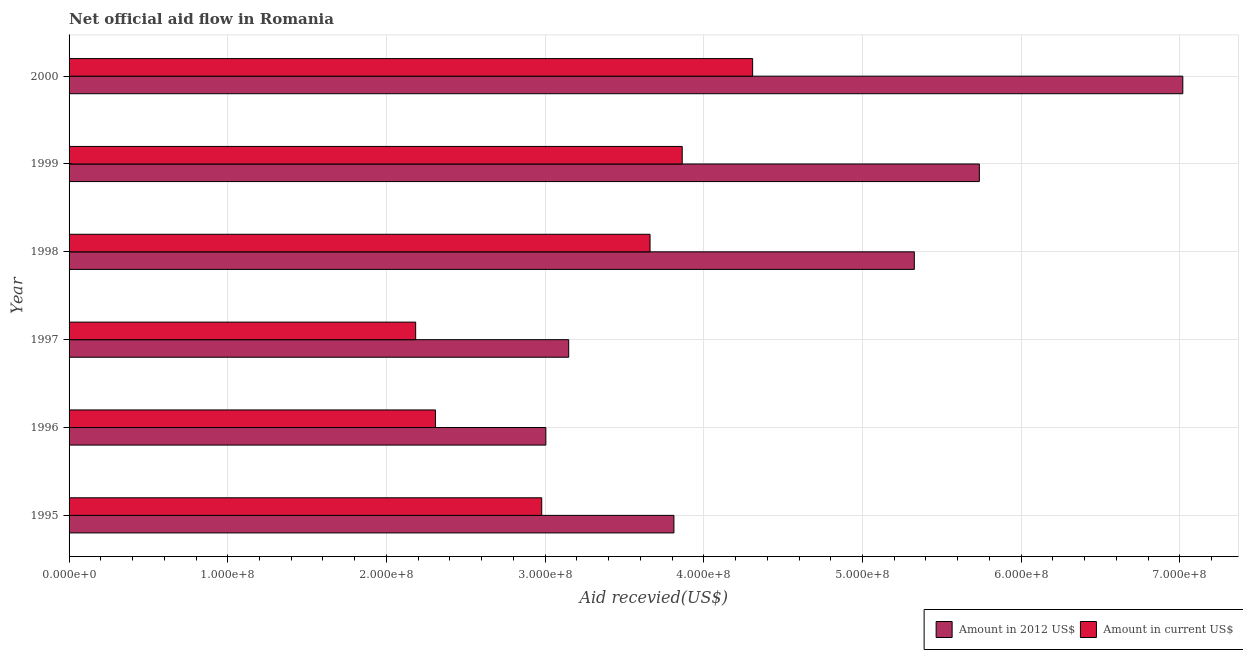How many groups of bars are there?
Provide a short and direct response. 6. Are the number of bars per tick equal to the number of legend labels?
Provide a short and direct response. Yes. How many bars are there on the 6th tick from the top?
Keep it short and to the point. 2. What is the label of the 6th group of bars from the top?
Your answer should be compact. 1995. In how many cases, is the number of bars for a given year not equal to the number of legend labels?
Make the answer very short. 0. What is the amount of aid received(expressed in us$) in 2000?
Provide a short and direct response. 4.31e+08. Across all years, what is the maximum amount of aid received(expressed in us$)?
Provide a succinct answer. 4.31e+08. Across all years, what is the minimum amount of aid received(expressed in 2012 us$)?
Provide a short and direct response. 3.00e+08. In which year was the amount of aid received(expressed in us$) maximum?
Make the answer very short. 2000. What is the total amount of aid received(expressed in 2012 us$) in the graph?
Your answer should be compact. 2.80e+09. What is the difference between the amount of aid received(expressed in us$) in 1995 and that in 1998?
Ensure brevity in your answer.  -6.83e+07. What is the difference between the amount of aid received(expressed in 2012 us$) in 1998 and the amount of aid received(expressed in us$) in 1999?
Your response must be concise. 1.46e+08. What is the average amount of aid received(expressed in 2012 us$) per year?
Ensure brevity in your answer.  4.67e+08. In the year 2000, what is the difference between the amount of aid received(expressed in us$) and amount of aid received(expressed in 2012 us$)?
Make the answer very short. -2.71e+08. In how many years, is the amount of aid received(expressed in us$) greater than 480000000 US$?
Keep it short and to the point. 0. What is the ratio of the amount of aid received(expressed in us$) in 1997 to that in 1999?
Your response must be concise. 0.56. Is the difference between the amount of aid received(expressed in 2012 us$) in 1998 and 2000 greater than the difference between the amount of aid received(expressed in us$) in 1998 and 2000?
Provide a succinct answer. No. What is the difference between the highest and the second highest amount of aid received(expressed in 2012 us$)?
Your answer should be compact. 1.28e+08. What is the difference between the highest and the lowest amount of aid received(expressed in us$)?
Provide a short and direct response. 2.12e+08. In how many years, is the amount of aid received(expressed in us$) greater than the average amount of aid received(expressed in us$) taken over all years?
Keep it short and to the point. 3. What does the 1st bar from the top in 1995 represents?
Offer a terse response. Amount in current US$. What does the 1st bar from the bottom in 1996 represents?
Make the answer very short. Amount in 2012 US$. How many bars are there?
Ensure brevity in your answer.  12. Are all the bars in the graph horizontal?
Your answer should be compact. Yes. What is the difference between two consecutive major ticks on the X-axis?
Offer a terse response. 1.00e+08. Are the values on the major ticks of X-axis written in scientific E-notation?
Provide a short and direct response. Yes. Does the graph contain grids?
Your response must be concise. Yes. How many legend labels are there?
Offer a very short reply. 2. How are the legend labels stacked?
Offer a terse response. Horizontal. What is the title of the graph?
Your answer should be compact. Net official aid flow in Romania. Does "Primary school" appear as one of the legend labels in the graph?
Offer a very short reply. No. What is the label or title of the X-axis?
Your answer should be compact. Aid recevied(US$). What is the label or title of the Y-axis?
Provide a succinct answer. Year. What is the Aid recevied(US$) of Amount in 2012 US$ in 1995?
Your response must be concise. 3.81e+08. What is the Aid recevied(US$) of Amount in current US$ in 1995?
Give a very brief answer. 2.98e+08. What is the Aid recevied(US$) in Amount in 2012 US$ in 1996?
Make the answer very short. 3.00e+08. What is the Aid recevied(US$) of Amount in current US$ in 1996?
Your answer should be compact. 2.31e+08. What is the Aid recevied(US$) of Amount in 2012 US$ in 1997?
Your response must be concise. 3.15e+08. What is the Aid recevied(US$) of Amount in current US$ in 1997?
Provide a succinct answer. 2.18e+08. What is the Aid recevied(US$) in Amount in 2012 US$ in 1998?
Offer a very short reply. 5.33e+08. What is the Aid recevied(US$) of Amount in current US$ in 1998?
Make the answer very short. 3.66e+08. What is the Aid recevied(US$) of Amount in 2012 US$ in 1999?
Provide a short and direct response. 5.74e+08. What is the Aid recevied(US$) of Amount in current US$ in 1999?
Provide a short and direct response. 3.86e+08. What is the Aid recevied(US$) in Amount in 2012 US$ in 2000?
Ensure brevity in your answer.  7.02e+08. What is the Aid recevied(US$) of Amount in current US$ in 2000?
Provide a short and direct response. 4.31e+08. Across all years, what is the maximum Aid recevied(US$) of Amount in 2012 US$?
Your response must be concise. 7.02e+08. Across all years, what is the maximum Aid recevied(US$) in Amount in current US$?
Ensure brevity in your answer.  4.31e+08. Across all years, what is the minimum Aid recevied(US$) in Amount in 2012 US$?
Ensure brevity in your answer.  3.00e+08. Across all years, what is the minimum Aid recevied(US$) of Amount in current US$?
Offer a terse response. 2.18e+08. What is the total Aid recevied(US$) in Amount in 2012 US$ in the graph?
Offer a terse response. 2.80e+09. What is the total Aid recevied(US$) in Amount in current US$ in the graph?
Provide a short and direct response. 1.93e+09. What is the difference between the Aid recevied(US$) of Amount in 2012 US$ in 1995 and that in 1996?
Your response must be concise. 8.07e+07. What is the difference between the Aid recevied(US$) in Amount in current US$ in 1995 and that in 1996?
Keep it short and to the point. 6.69e+07. What is the difference between the Aid recevied(US$) in Amount in 2012 US$ in 1995 and that in 1997?
Your answer should be compact. 6.63e+07. What is the difference between the Aid recevied(US$) of Amount in current US$ in 1995 and that in 1997?
Your answer should be very brief. 7.94e+07. What is the difference between the Aid recevied(US$) of Amount in 2012 US$ in 1995 and that in 1998?
Ensure brevity in your answer.  -1.52e+08. What is the difference between the Aid recevied(US$) in Amount in current US$ in 1995 and that in 1998?
Ensure brevity in your answer.  -6.83e+07. What is the difference between the Aid recevied(US$) in Amount in 2012 US$ in 1995 and that in 1999?
Give a very brief answer. -1.92e+08. What is the difference between the Aid recevied(US$) in Amount in current US$ in 1995 and that in 1999?
Provide a short and direct response. -8.85e+07. What is the difference between the Aid recevied(US$) in Amount in 2012 US$ in 1995 and that in 2000?
Offer a terse response. -3.21e+08. What is the difference between the Aid recevied(US$) of Amount in current US$ in 1995 and that in 2000?
Provide a succinct answer. -1.33e+08. What is the difference between the Aid recevied(US$) of Amount in 2012 US$ in 1996 and that in 1997?
Offer a terse response. -1.44e+07. What is the difference between the Aid recevied(US$) in Amount in current US$ in 1996 and that in 1997?
Provide a short and direct response. 1.25e+07. What is the difference between the Aid recevied(US$) of Amount in 2012 US$ in 1996 and that in 1998?
Provide a succinct answer. -2.32e+08. What is the difference between the Aid recevied(US$) in Amount in current US$ in 1996 and that in 1998?
Make the answer very short. -1.35e+08. What is the difference between the Aid recevied(US$) of Amount in 2012 US$ in 1996 and that in 1999?
Give a very brief answer. -2.73e+08. What is the difference between the Aid recevied(US$) in Amount in current US$ in 1996 and that in 1999?
Your response must be concise. -1.55e+08. What is the difference between the Aid recevied(US$) of Amount in 2012 US$ in 1996 and that in 2000?
Give a very brief answer. -4.01e+08. What is the difference between the Aid recevied(US$) of Amount in current US$ in 1996 and that in 2000?
Your answer should be very brief. -2.00e+08. What is the difference between the Aid recevied(US$) in Amount in 2012 US$ in 1997 and that in 1998?
Provide a short and direct response. -2.18e+08. What is the difference between the Aid recevied(US$) in Amount in current US$ in 1997 and that in 1998?
Offer a terse response. -1.48e+08. What is the difference between the Aid recevied(US$) of Amount in 2012 US$ in 1997 and that in 1999?
Provide a succinct answer. -2.59e+08. What is the difference between the Aid recevied(US$) of Amount in current US$ in 1997 and that in 1999?
Your answer should be compact. -1.68e+08. What is the difference between the Aid recevied(US$) in Amount in 2012 US$ in 1997 and that in 2000?
Your response must be concise. -3.87e+08. What is the difference between the Aid recevied(US$) in Amount in current US$ in 1997 and that in 2000?
Ensure brevity in your answer.  -2.12e+08. What is the difference between the Aid recevied(US$) in Amount in 2012 US$ in 1998 and that in 1999?
Your answer should be compact. -4.10e+07. What is the difference between the Aid recevied(US$) of Amount in current US$ in 1998 and that in 1999?
Your answer should be very brief. -2.03e+07. What is the difference between the Aid recevied(US$) in Amount in 2012 US$ in 1998 and that in 2000?
Your answer should be very brief. -1.69e+08. What is the difference between the Aid recevied(US$) in Amount in current US$ in 1998 and that in 2000?
Your answer should be compact. -6.46e+07. What is the difference between the Aid recevied(US$) in Amount in 2012 US$ in 1999 and that in 2000?
Provide a succinct answer. -1.28e+08. What is the difference between the Aid recevied(US$) in Amount in current US$ in 1999 and that in 2000?
Provide a short and direct response. -4.44e+07. What is the difference between the Aid recevied(US$) in Amount in 2012 US$ in 1995 and the Aid recevied(US$) in Amount in current US$ in 1996?
Your answer should be very brief. 1.50e+08. What is the difference between the Aid recevied(US$) in Amount in 2012 US$ in 1995 and the Aid recevied(US$) in Amount in current US$ in 1997?
Provide a succinct answer. 1.63e+08. What is the difference between the Aid recevied(US$) of Amount in 2012 US$ in 1995 and the Aid recevied(US$) of Amount in current US$ in 1998?
Make the answer very short. 1.50e+07. What is the difference between the Aid recevied(US$) of Amount in 2012 US$ in 1995 and the Aid recevied(US$) of Amount in current US$ in 1999?
Make the answer very short. -5.23e+06. What is the difference between the Aid recevied(US$) of Amount in 2012 US$ in 1995 and the Aid recevied(US$) of Amount in current US$ in 2000?
Your answer should be compact. -4.96e+07. What is the difference between the Aid recevied(US$) in Amount in 2012 US$ in 1996 and the Aid recevied(US$) in Amount in current US$ in 1997?
Keep it short and to the point. 8.20e+07. What is the difference between the Aid recevied(US$) of Amount in 2012 US$ in 1996 and the Aid recevied(US$) of Amount in current US$ in 1998?
Offer a terse response. -6.57e+07. What is the difference between the Aid recevied(US$) of Amount in 2012 US$ in 1996 and the Aid recevied(US$) of Amount in current US$ in 1999?
Provide a succinct answer. -8.59e+07. What is the difference between the Aid recevied(US$) in Amount in 2012 US$ in 1996 and the Aid recevied(US$) in Amount in current US$ in 2000?
Your response must be concise. -1.30e+08. What is the difference between the Aid recevied(US$) in Amount in 2012 US$ in 1997 and the Aid recevied(US$) in Amount in current US$ in 1998?
Provide a succinct answer. -5.13e+07. What is the difference between the Aid recevied(US$) of Amount in 2012 US$ in 1997 and the Aid recevied(US$) of Amount in current US$ in 1999?
Make the answer very short. -7.15e+07. What is the difference between the Aid recevied(US$) of Amount in 2012 US$ in 1997 and the Aid recevied(US$) of Amount in current US$ in 2000?
Give a very brief answer. -1.16e+08. What is the difference between the Aid recevied(US$) of Amount in 2012 US$ in 1998 and the Aid recevied(US$) of Amount in current US$ in 1999?
Your answer should be very brief. 1.46e+08. What is the difference between the Aid recevied(US$) in Amount in 2012 US$ in 1998 and the Aid recevied(US$) in Amount in current US$ in 2000?
Your answer should be very brief. 1.02e+08. What is the difference between the Aid recevied(US$) in Amount in 2012 US$ in 1999 and the Aid recevied(US$) in Amount in current US$ in 2000?
Your answer should be very brief. 1.43e+08. What is the average Aid recevied(US$) of Amount in 2012 US$ per year?
Offer a terse response. 4.67e+08. What is the average Aid recevied(US$) of Amount in current US$ per year?
Keep it short and to the point. 3.22e+08. In the year 1995, what is the difference between the Aid recevied(US$) of Amount in 2012 US$ and Aid recevied(US$) of Amount in current US$?
Give a very brief answer. 8.33e+07. In the year 1996, what is the difference between the Aid recevied(US$) in Amount in 2012 US$ and Aid recevied(US$) in Amount in current US$?
Offer a very short reply. 6.95e+07. In the year 1997, what is the difference between the Aid recevied(US$) in Amount in 2012 US$ and Aid recevied(US$) in Amount in current US$?
Your answer should be very brief. 9.64e+07. In the year 1998, what is the difference between the Aid recevied(US$) of Amount in 2012 US$ and Aid recevied(US$) of Amount in current US$?
Your response must be concise. 1.67e+08. In the year 1999, what is the difference between the Aid recevied(US$) in Amount in 2012 US$ and Aid recevied(US$) in Amount in current US$?
Your answer should be very brief. 1.87e+08. In the year 2000, what is the difference between the Aid recevied(US$) of Amount in 2012 US$ and Aid recevied(US$) of Amount in current US$?
Give a very brief answer. 2.71e+08. What is the ratio of the Aid recevied(US$) of Amount in 2012 US$ in 1995 to that in 1996?
Your response must be concise. 1.27. What is the ratio of the Aid recevied(US$) of Amount in current US$ in 1995 to that in 1996?
Provide a succinct answer. 1.29. What is the ratio of the Aid recevied(US$) in Amount in 2012 US$ in 1995 to that in 1997?
Offer a very short reply. 1.21. What is the ratio of the Aid recevied(US$) of Amount in current US$ in 1995 to that in 1997?
Your answer should be compact. 1.36. What is the ratio of the Aid recevied(US$) of Amount in 2012 US$ in 1995 to that in 1998?
Your answer should be compact. 0.72. What is the ratio of the Aid recevied(US$) of Amount in current US$ in 1995 to that in 1998?
Ensure brevity in your answer.  0.81. What is the ratio of the Aid recevied(US$) of Amount in 2012 US$ in 1995 to that in 1999?
Your answer should be compact. 0.66. What is the ratio of the Aid recevied(US$) in Amount in current US$ in 1995 to that in 1999?
Offer a terse response. 0.77. What is the ratio of the Aid recevied(US$) in Amount in 2012 US$ in 1995 to that in 2000?
Give a very brief answer. 0.54. What is the ratio of the Aid recevied(US$) in Amount in current US$ in 1995 to that in 2000?
Your answer should be very brief. 0.69. What is the ratio of the Aid recevied(US$) of Amount in 2012 US$ in 1996 to that in 1997?
Give a very brief answer. 0.95. What is the ratio of the Aid recevied(US$) in Amount in current US$ in 1996 to that in 1997?
Make the answer very short. 1.06. What is the ratio of the Aid recevied(US$) in Amount in 2012 US$ in 1996 to that in 1998?
Make the answer very short. 0.56. What is the ratio of the Aid recevied(US$) of Amount in current US$ in 1996 to that in 1998?
Provide a short and direct response. 0.63. What is the ratio of the Aid recevied(US$) of Amount in 2012 US$ in 1996 to that in 1999?
Make the answer very short. 0.52. What is the ratio of the Aid recevied(US$) of Amount in current US$ in 1996 to that in 1999?
Your answer should be compact. 0.6. What is the ratio of the Aid recevied(US$) of Amount in 2012 US$ in 1996 to that in 2000?
Provide a succinct answer. 0.43. What is the ratio of the Aid recevied(US$) in Amount in current US$ in 1996 to that in 2000?
Your answer should be compact. 0.54. What is the ratio of the Aid recevied(US$) of Amount in 2012 US$ in 1997 to that in 1998?
Make the answer very short. 0.59. What is the ratio of the Aid recevied(US$) of Amount in current US$ in 1997 to that in 1998?
Your response must be concise. 0.6. What is the ratio of the Aid recevied(US$) of Amount in 2012 US$ in 1997 to that in 1999?
Offer a very short reply. 0.55. What is the ratio of the Aid recevied(US$) of Amount in current US$ in 1997 to that in 1999?
Your answer should be compact. 0.57. What is the ratio of the Aid recevied(US$) of Amount in 2012 US$ in 1997 to that in 2000?
Offer a terse response. 0.45. What is the ratio of the Aid recevied(US$) of Amount in current US$ in 1997 to that in 2000?
Your answer should be very brief. 0.51. What is the ratio of the Aid recevied(US$) in Amount in current US$ in 1998 to that in 1999?
Keep it short and to the point. 0.95. What is the ratio of the Aid recevied(US$) of Amount in 2012 US$ in 1998 to that in 2000?
Keep it short and to the point. 0.76. What is the ratio of the Aid recevied(US$) in Amount in current US$ in 1998 to that in 2000?
Your answer should be very brief. 0.85. What is the ratio of the Aid recevied(US$) in Amount in 2012 US$ in 1999 to that in 2000?
Ensure brevity in your answer.  0.82. What is the ratio of the Aid recevied(US$) of Amount in current US$ in 1999 to that in 2000?
Give a very brief answer. 0.9. What is the difference between the highest and the second highest Aid recevied(US$) in Amount in 2012 US$?
Keep it short and to the point. 1.28e+08. What is the difference between the highest and the second highest Aid recevied(US$) of Amount in current US$?
Keep it short and to the point. 4.44e+07. What is the difference between the highest and the lowest Aid recevied(US$) in Amount in 2012 US$?
Your answer should be very brief. 4.01e+08. What is the difference between the highest and the lowest Aid recevied(US$) in Amount in current US$?
Make the answer very short. 2.12e+08. 